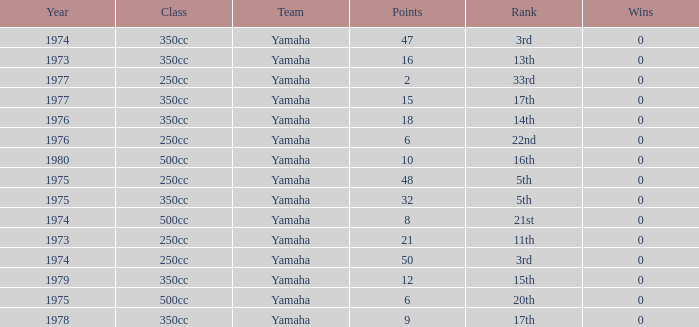How many Points have a Rank of 17th, and Wins larger than 0? 0.0. 